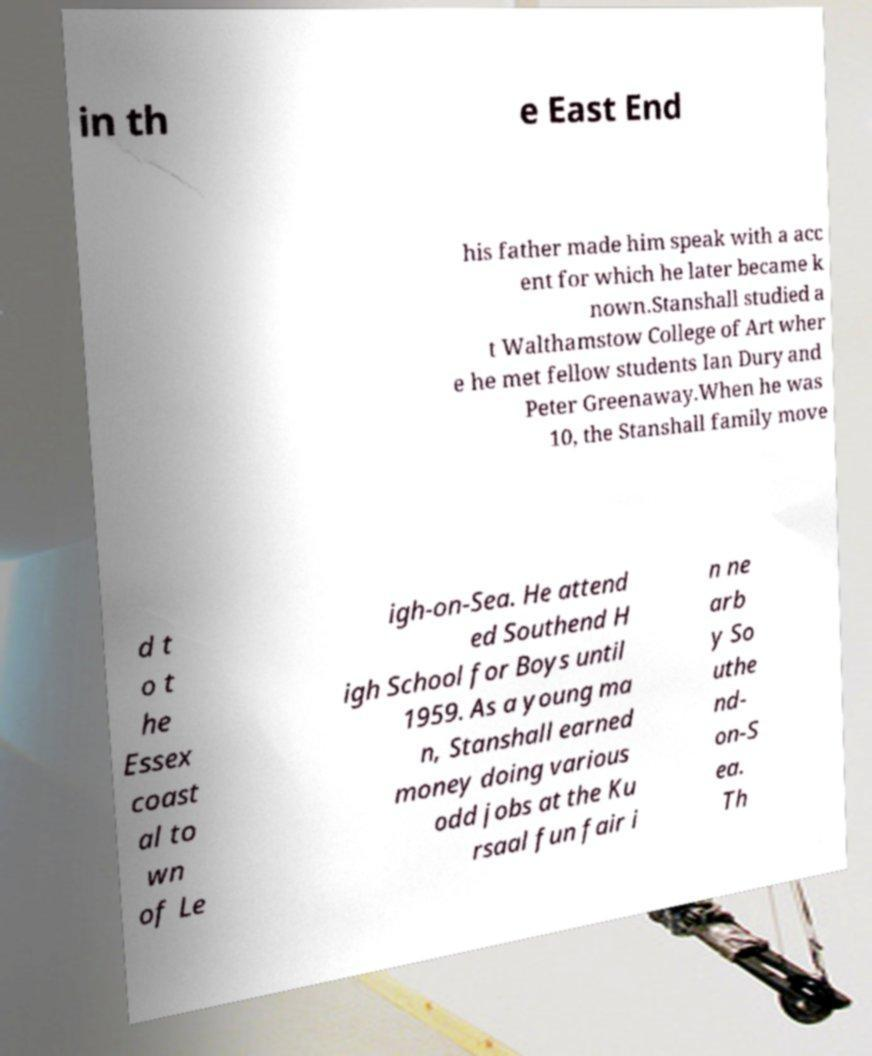What messages or text are displayed in this image? I need them in a readable, typed format. in th e East End his father made him speak with a acc ent for which he later became k nown.Stanshall studied a t Walthamstow College of Art wher e he met fellow students Ian Dury and Peter Greenaway.When he was 10, the Stanshall family move d t o t he Essex coast al to wn of Le igh-on-Sea. He attend ed Southend H igh School for Boys until 1959. As a young ma n, Stanshall earned money doing various odd jobs at the Ku rsaal fun fair i n ne arb y So uthe nd- on-S ea. Th 